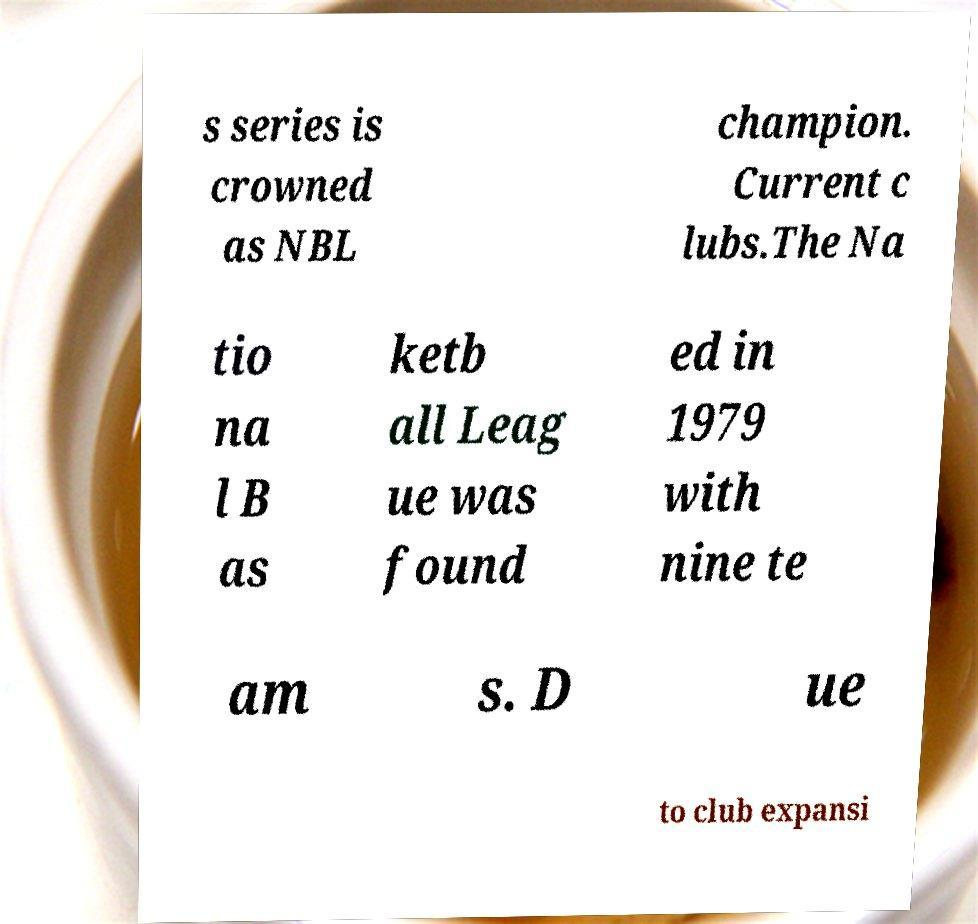Could you assist in decoding the text presented in this image and type it out clearly? s series is crowned as NBL champion. Current c lubs.The Na tio na l B as ketb all Leag ue was found ed in 1979 with nine te am s. D ue to club expansi 